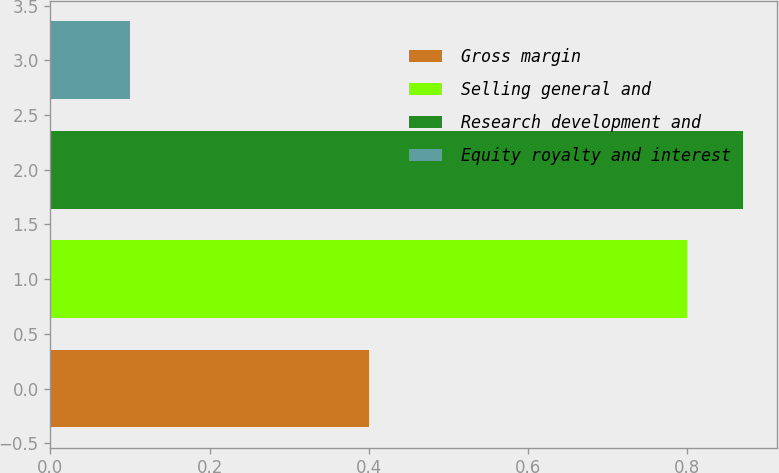Convert chart. <chart><loc_0><loc_0><loc_500><loc_500><bar_chart><fcel>Gross margin<fcel>Selling general and<fcel>Research development and<fcel>Equity royalty and interest<nl><fcel>0.4<fcel>0.8<fcel>0.87<fcel>0.1<nl></chart> 